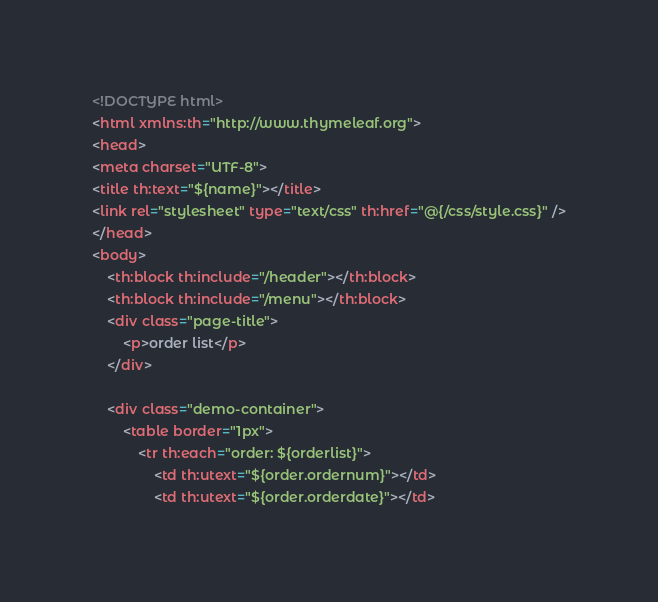<code> <loc_0><loc_0><loc_500><loc_500><_HTML_><!DOCTYPE html>
<html xmlns:th="http://www.thymeleaf.org">
<head>
<meta charset="UTF-8">
<title th:text="${name}"></title>
<link rel="stylesheet" type="text/css" th:href="@{/css/style.css}" />
</head>
<body>
	<th:block th:include="/header"></th:block>
	<th:block th:include="/menu"></th:block>
	<div class="page-title">
		<p>order list</p>
	</div>

	<div class="demo-container">
		<table border="1px">
			<tr th:each="order: ${orderlist}">
				<td th:utext="${order.ordernum}"></td>
				<td th:utext="${order.orderdate}"></td></code> 